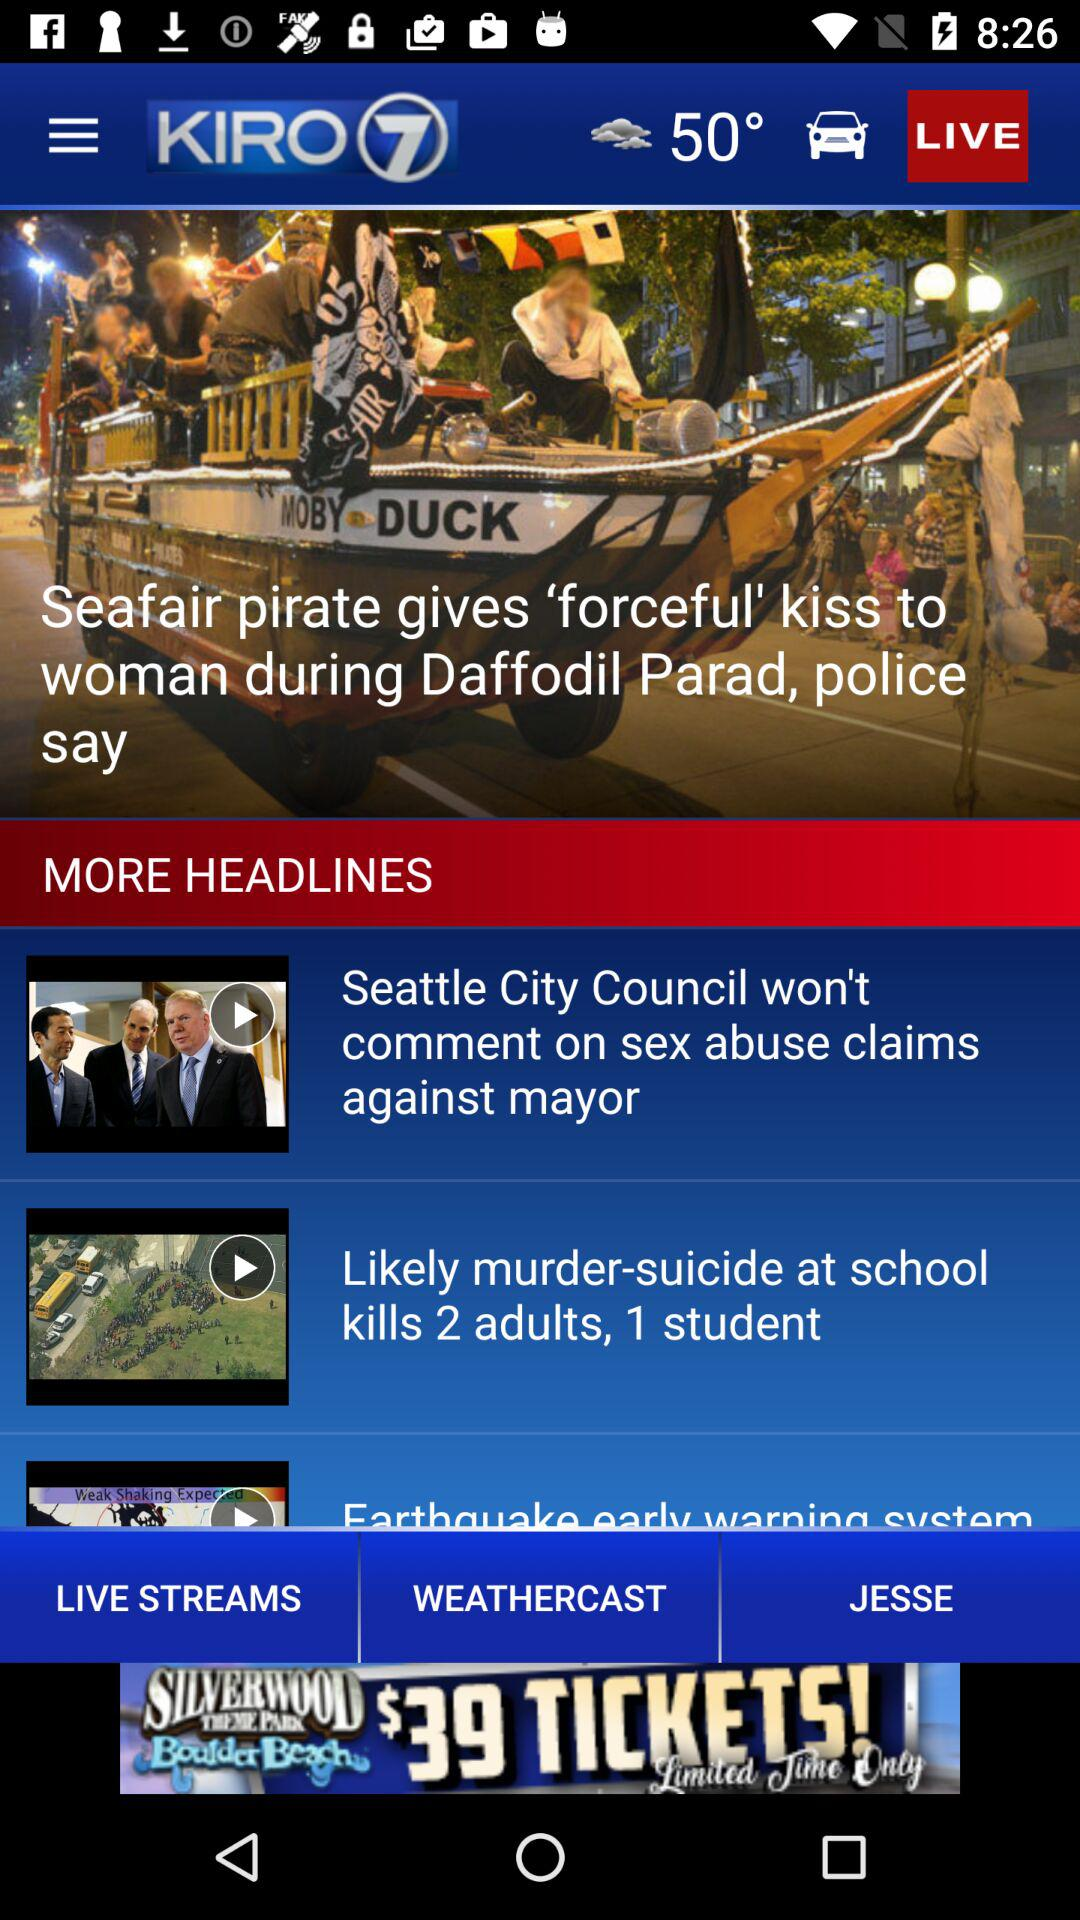What is the temperature? The temperature is 50°. 